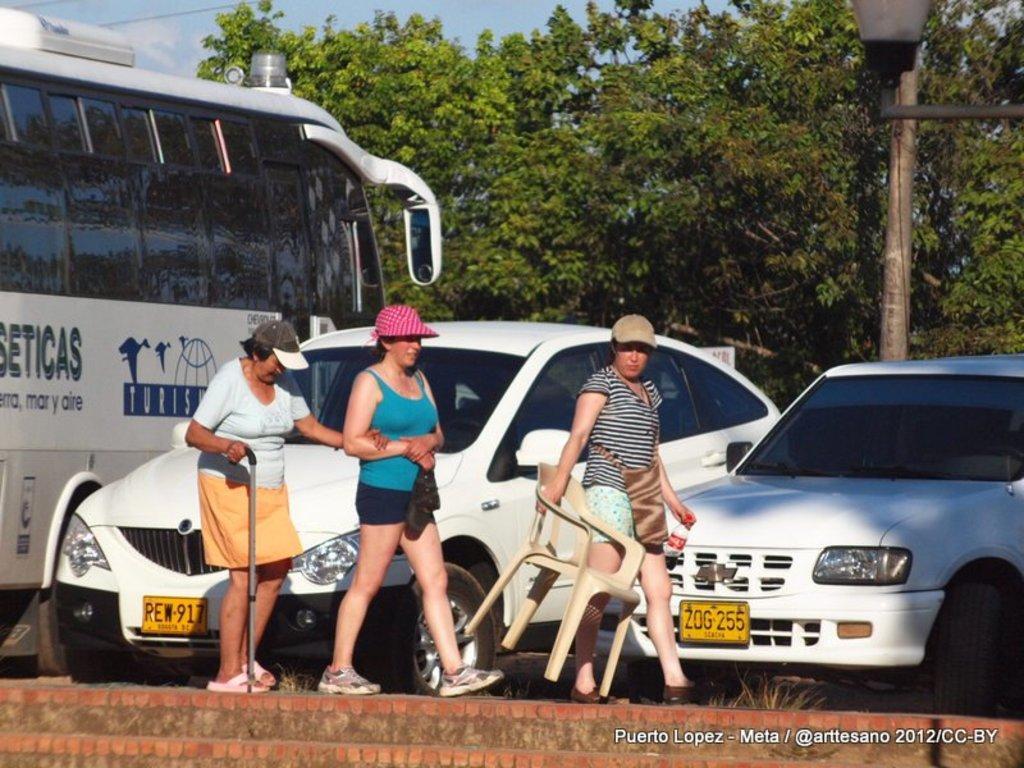Can you describe this image briefly? In this picture we can see three women, among them a woman holding a chair and a bottle and another woman holding a stick. Behind the women, there are cars, a bus, trees, a pole and the sky. In the bottom right corner of the image, there is a watermark. In the top right corner of the image, there is a street light. At the bottom of the image, there is a wall. 